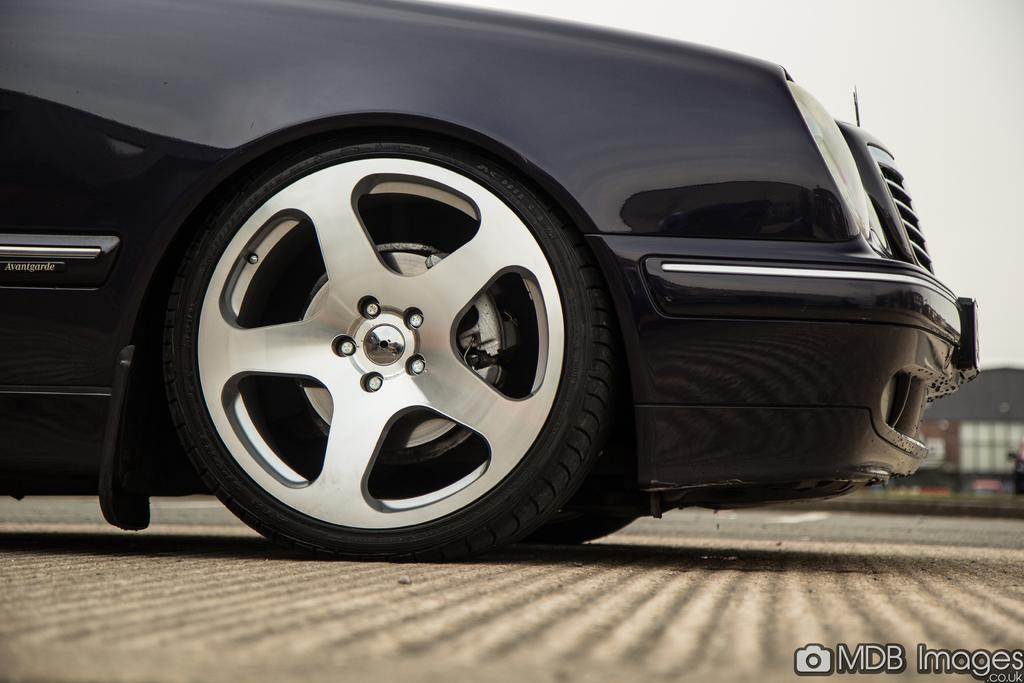What color is the car in the image? The car in the image is black. What can be seen in the background of the image? There is a building in the background of the image. Where is the text located in the image? The text is at the right bottom of the image. What is visible at the top of the image? The sky is visible at the top of the image. What type of pie is being served in the image? There is no pie present in the image. Can you hear thunder in the image? There is no sound or indication of thunder in the image. 